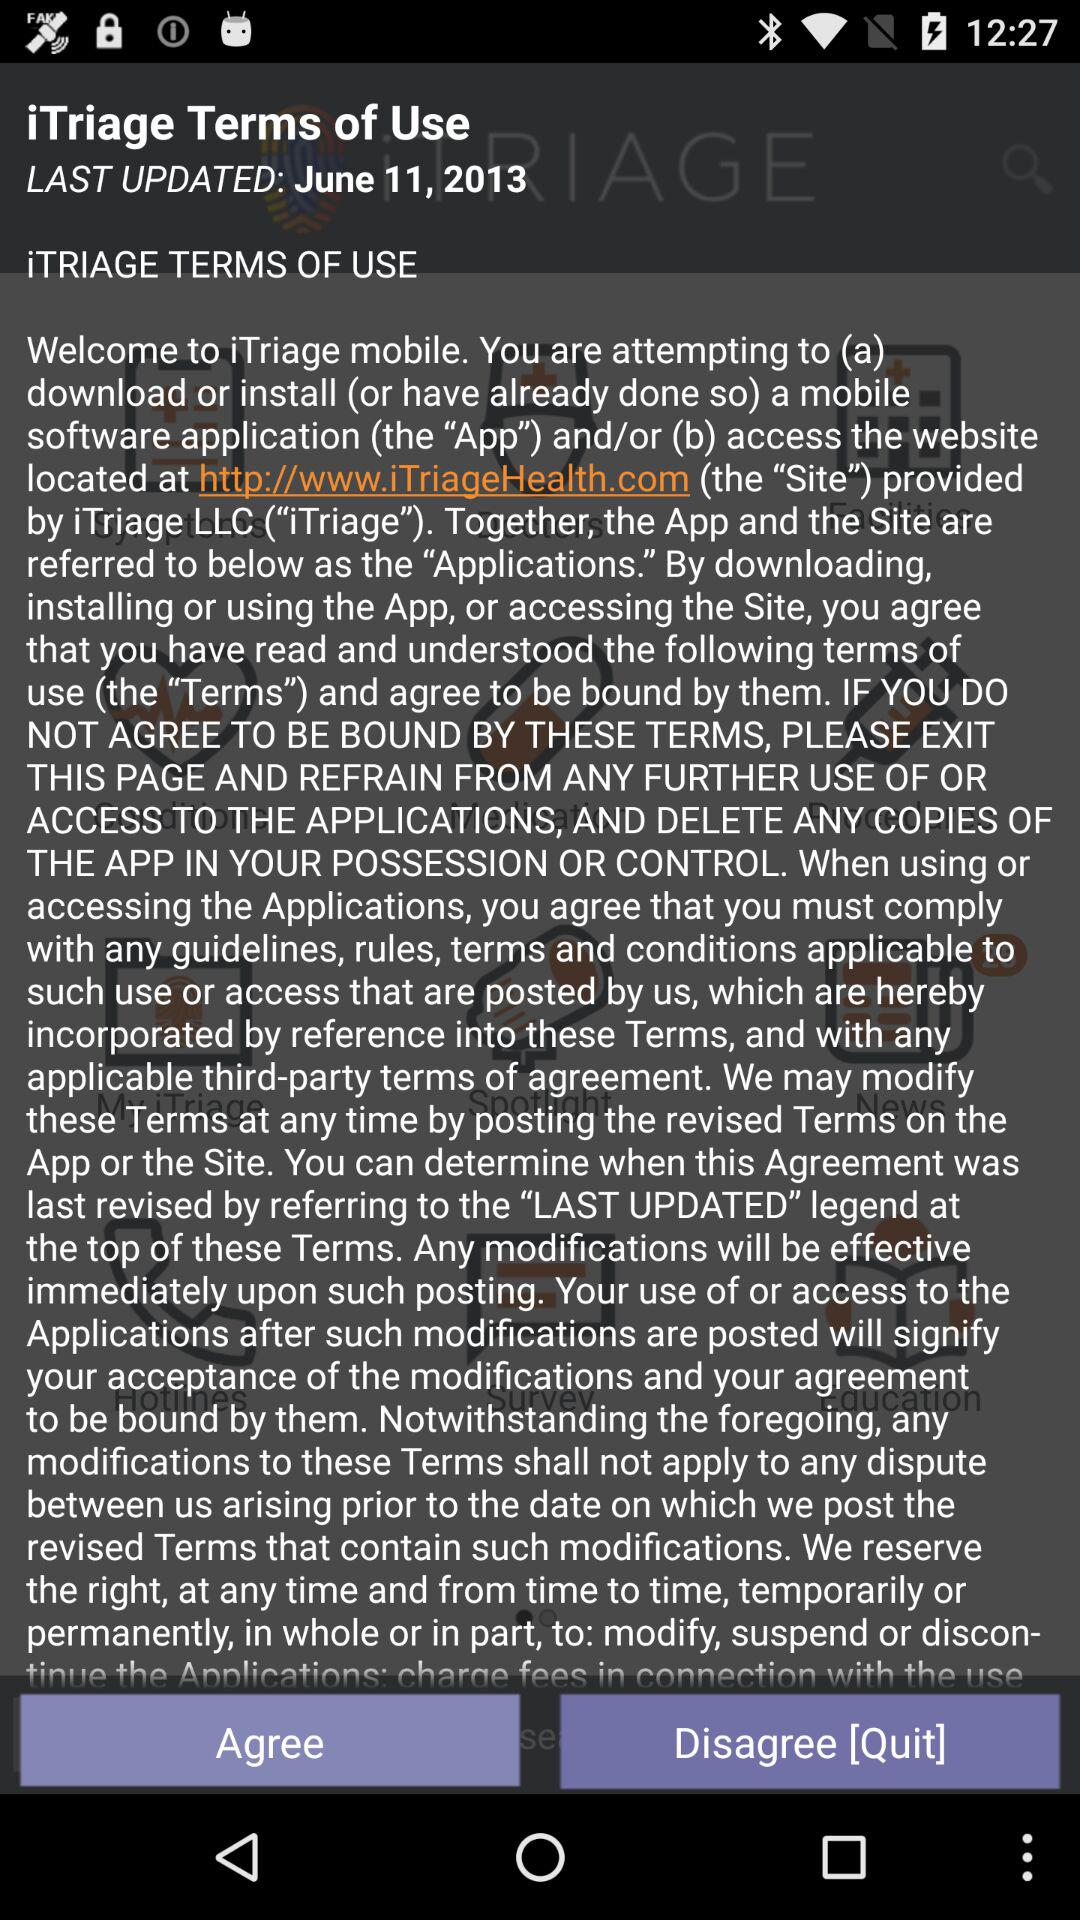What is the last updated date of the terms of use? The last updated date is June 11, 2013. 